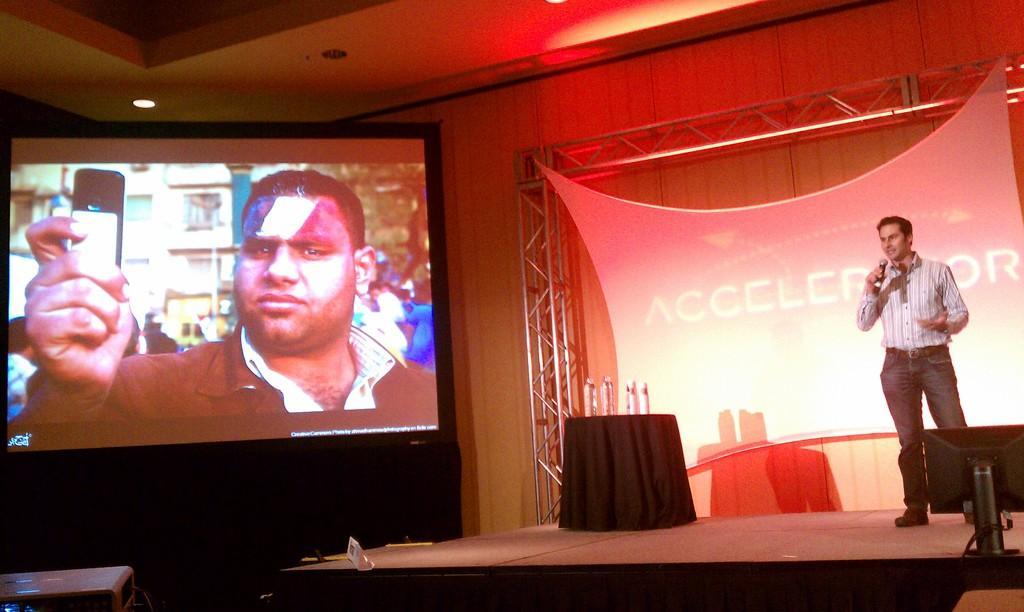Could you give a brief overview of what you see in this image? In this image there is a man standing on the dais. He is holding a microphone. Beside him there is a table. There are bottles on the table. Behind him there is a banner with text on the wall. To the left there is a projector board. There are images displayed on the board. In the image there is a man holding a mobile phone. In the bottom left there is a projector. In the bottom right there is a monitor. At the top there are lights to the ceiling. 